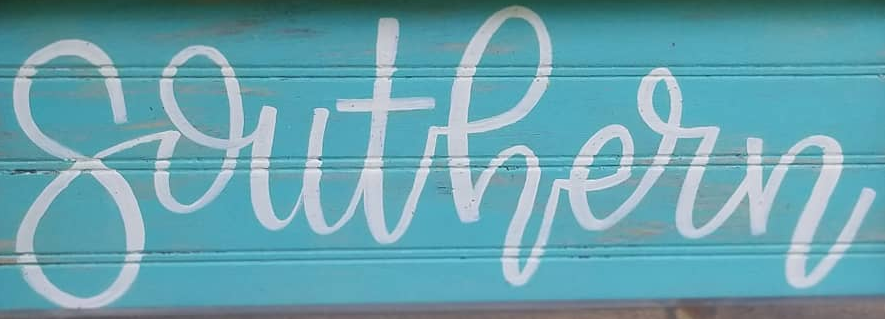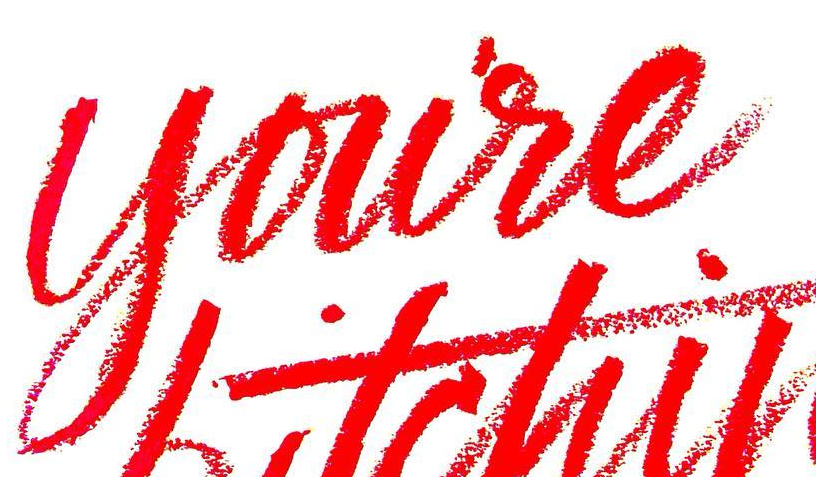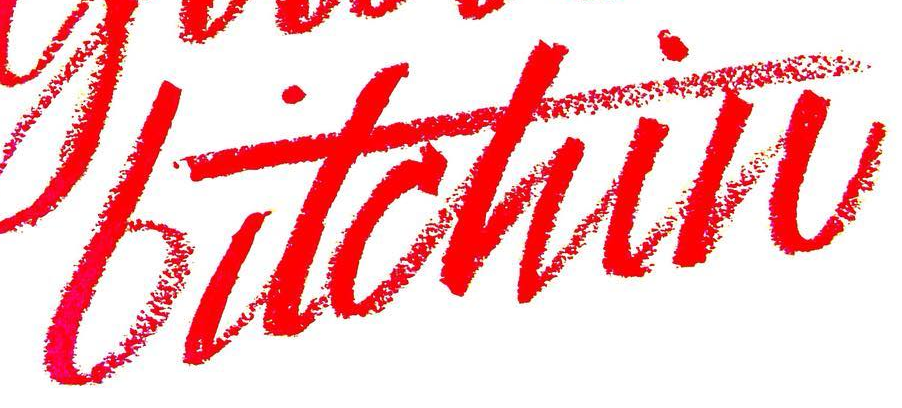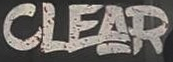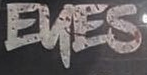Identify the words shown in these images in order, separated by a semicolon. southern; youre; bitchin; CLEAR; EKES 